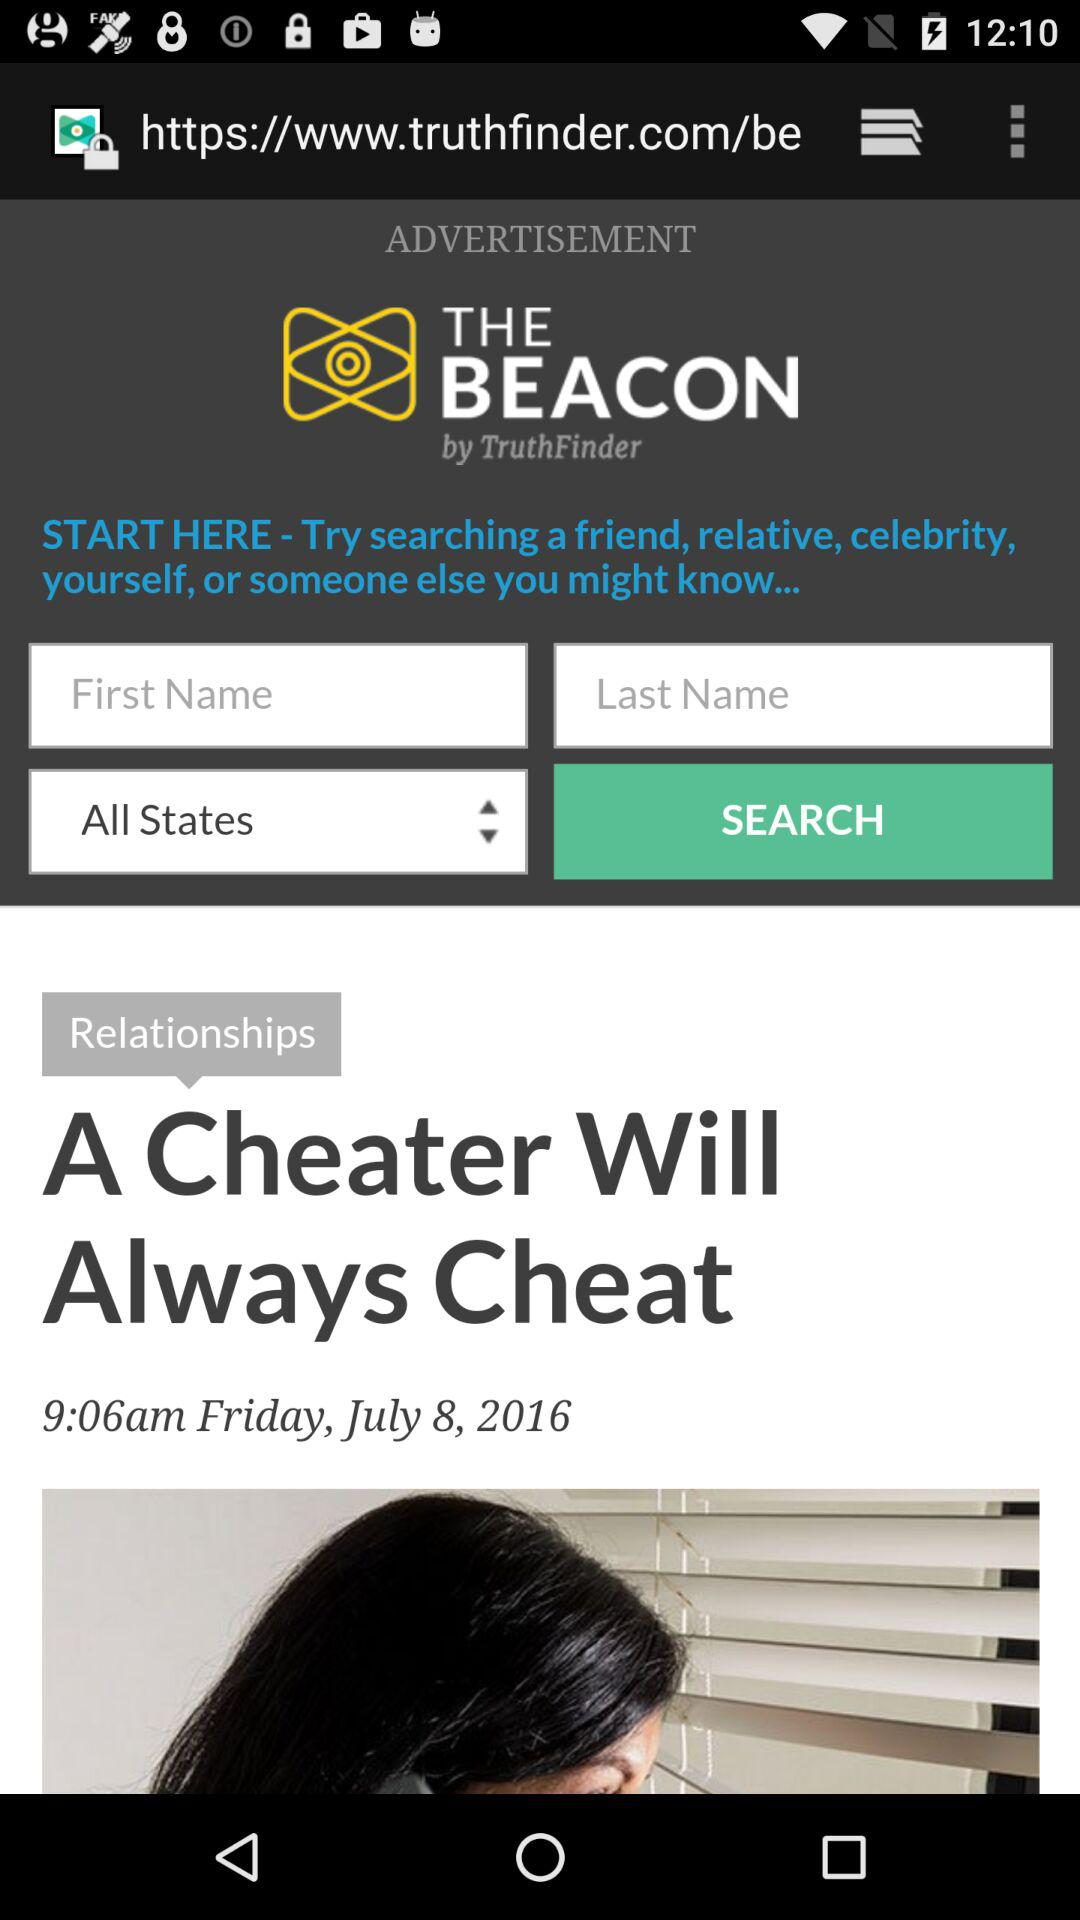What day was July 8, 2016? The day was Friday. 